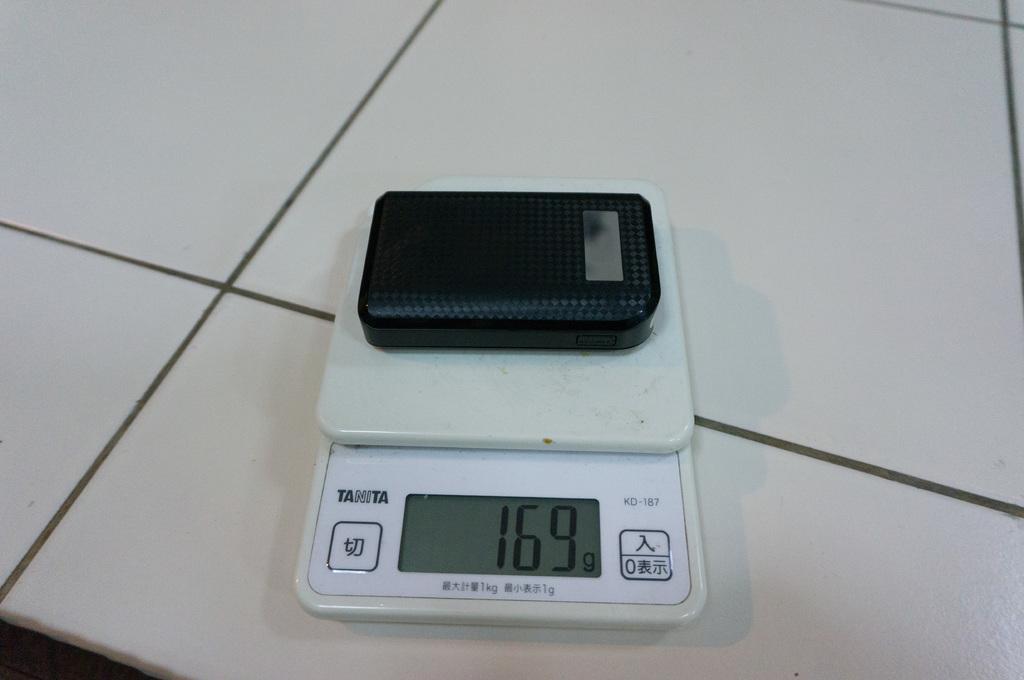How much does the device weigh?
Keep it short and to the point. 169g. What is the brand of the scale?
Offer a terse response. Tanita. 